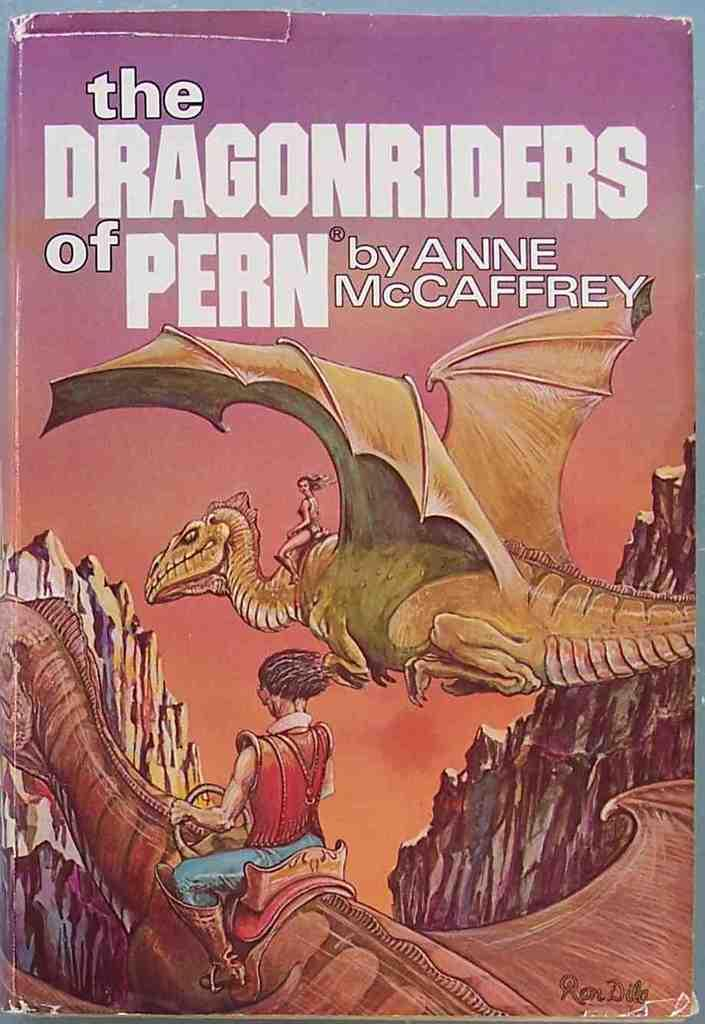<image>
Write a terse but informative summary of the picture. A book titled The Dragonriders of Pern by Anne McCaffrey. 